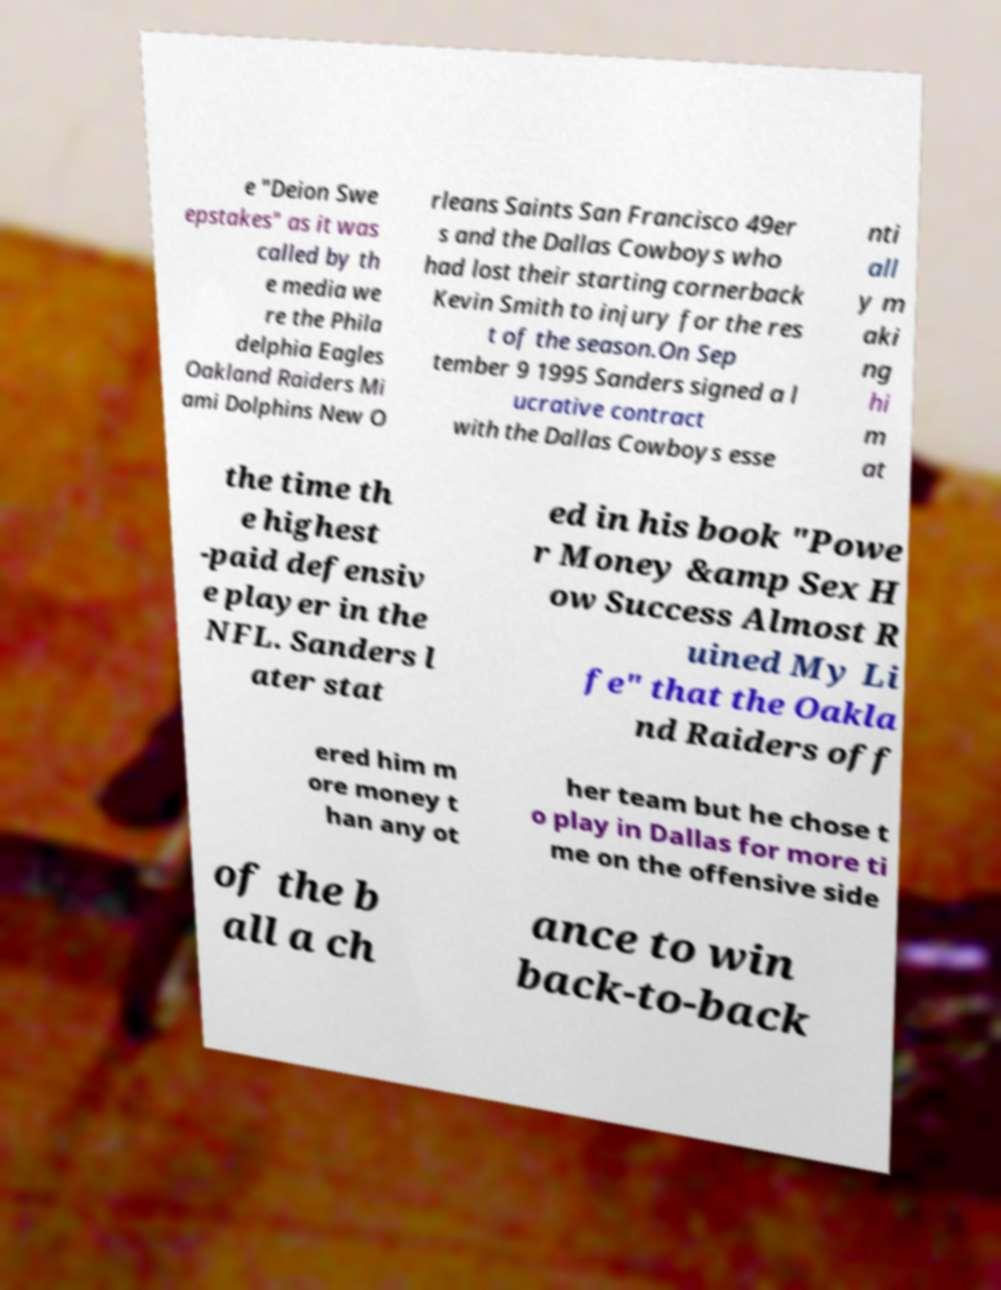Can you read and provide the text displayed in the image?This photo seems to have some interesting text. Can you extract and type it out for me? e "Deion Swe epstakes" as it was called by th e media we re the Phila delphia Eagles Oakland Raiders Mi ami Dolphins New O rleans Saints San Francisco 49er s and the Dallas Cowboys who had lost their starting cornerback Kevin Smith to injury for the res t of the season.On Sep tember 9 1995 Sanders signed a l ucrative contract with the Dallas Cowboys esse nti all y m aki ng hi m at the time th e highest -paid defensiv e player in the NFL. Sanders l ater stat ed in his book "Powe r Money &amp Sex H ow Success Almost R uined My Li fe" that the Oakla nd Raiders off ered him m ore money t han any ot her team but he chose t o play in Dallas for more ti me on the offensive side of the b all a ch ance to win back-to-back 